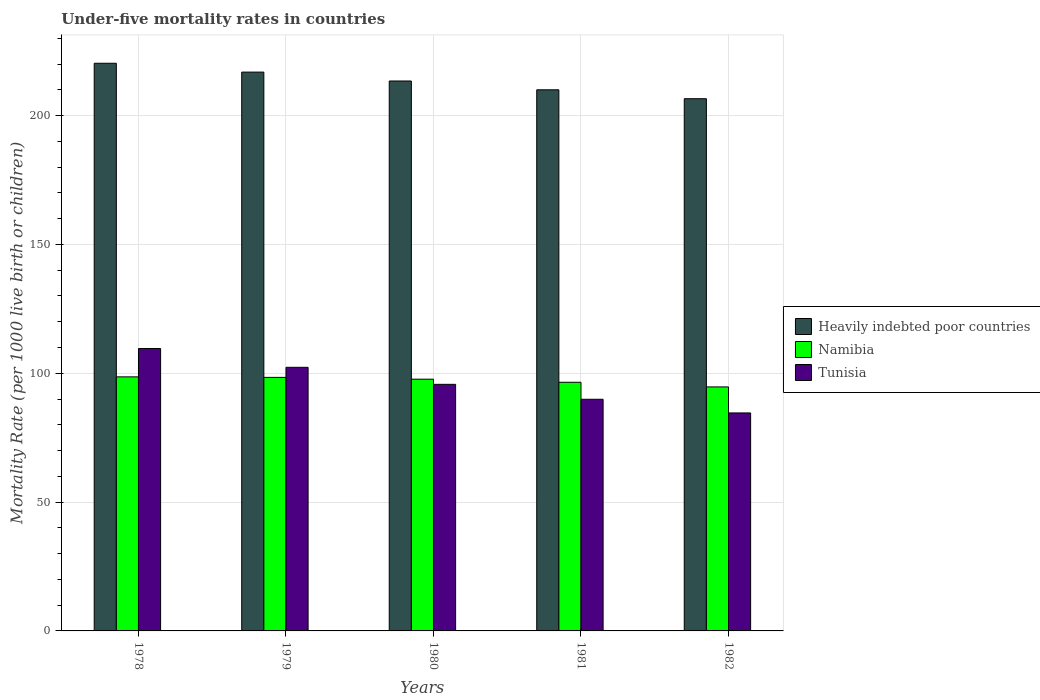In how many cases, is the number of bars for a given year not equal to the number of legend labels?
Your response must be concise. 0. What is the under-five mortality rate in Namibia in 1980?
Offer a very short reply. 97.7. Across all years, what is the maximum under-five mortality rate in Tunisia?
Provide a short and direct response. 109.6. Across all years, what is the minimum under-five mortality rate in Namibia?
Your answer should be very brief. 94.7. In which year was the under-five mortality rate in Heavily indebted poor countries maximum?
Offer a terse response. 1978. What is the total under-five mortality rate in Namibia in the graph?
Give a very brief answer. 485.9. What is the difference between the under-five mortality rate in Tunisia in 1981 and that in 1982?
Keep it short and to the point. 5.3. What is the difference between the under-five mortality rate in Heavily indebted poor countries in 1981 and the under-five mortality rate in Namibia in 1979?
Your response must be concise. 111.61. What is the average under-five mortality rate in Tunisia per year?
Provide a short and direct response. 96.42. In how many years, is the under-five mortality rate in Namibia greater than 120?
Ensure brevity in your answer.  0. What is the ratio of the under-five mortality rate in Heavily indebted poor countries in 1979 to that in 1981?
Keep it short and to the point. 1.03. Is the under-five mortality rate in Namibia in 1979 less than that in 1982?
Offer a very short reply. No. What is the difference between the highest and the second highest under-five mortality rate in Heavily indebted poor countries?
Your answer should be compact. 3.43. What is the difference between the highest and the lowest under-five mortality rate in Namibia?
Your answer should be compact. 3.9. In how many years, is the under-five mortality rate in Heavily indebted poor countries greater than the average under-five mortality rate in Heavily indebted poor countries taken over all years?
Provide a short and direct response. 2. Is the sum of the under-five mortality rate in Tunisia in 1979 and 1982 greater than the maximum under-five mortality rate in Heavily indebted poor countries across all years?
Give a very brief answer. No. What does the 2nd bar from the left in 1980 represents?
Your response must be concise. Namibia. What does the 2nd bar from the right in 1981 represents?
Your answer should be compact. Namibia. Is it the case that in every year, the sum of the under-five mortality rate in Heavily indebted poor countries and under-five mortality rate in Namibia is greater than the under-five mortality rate in Tunisia?
Provide a short and direct response. Yes. How many years are there in the graph?
Ensure brevity in your answer.  5. What is the difference between two consecutive major ticks on the Y-axis?
Offer a very short reply. 50. Are the values on the major ticks of Y-axis written in scientific E-notation?
Keep it short and to the point. No. Does the graph contain grids?
Keep it short and to the point. Yes. Where does the legend appear in the graph?
Your answer should be compact. Center right. How many legend labels are there?
Your answer should be very brief. 3. How are the legend labels stacked?
Keep it short and to the point. Vertical. What is the title of the graph?
Ensure brevity in your answer.  Under-five mortality rates in countries. Does "Kosovo" appear as one of the legend labels in the graph?
Your answer should be compact. No. What is the label or title of the X-axis?
Ensure brevity in your answer.  Years. What is the label or title of the Y-axis?
Ensure brevity in your answer.  Mortality Rate (per 1000 live birth or children). What is the Mortality Rate (per 1000 live birth or children) of Heavily indebted poor countries in 1978?
Provide a short and direct response. 220.31. What is the Mortality Rate (per 1000 live birth or children) in Namibia in 1978?
Provide a succinct answer. 98.6. What is the Mortality Rate (per 1000 live birth or children) in Tunisia in 1978?
Ensure brevity in your answer.  109.6. What is the Mortality Rate (per 1000 live birth or children) of Heavily indebted poor countries in 1979?
Ensure brevity in your answer.  216.87. What is the Mortality Rate (per 1000 live birth or children) in Namibia in 1979?
Give a very brief answer. 98.4. What is the Mortality Rate (per 1000 live birth or children) of Tunisia in 1979?
Offer a terse response. 102.3. What is the Mortality Rate (per 1000 live birth or children) in Heavily indebted poor countries in 1980?
Make the answer very short. 213.42. What is the Mortality Rate (per 1000 live birth or children) of Namibia in 1980?
Keep it short and to the point. 97.7. What is the Mortality Rate (per 1000 live birth or children) of Tunisia in 1980?
Your response must be concise. 95.7. What is the Mortality Rate (per 1000 live birth or children) of Heavily indebted poor countries in 1981?
Offer a very short reply. 210.01. What is the Mortality Rate (per 1000 live birth or children) of Namibia in 1981?
Ensure brevity in your answer.  96.5. What is the Mortality Rate (per 1000 live birth or children) in Tunisia in 1981?
Your answer should be very brief. 89.9. What is the Mortality Rate (per 1000 live birth or children) of Heavily indebted poor countries in 1982?
Keep it short and to the point. 206.55. What is the Mortality Rate (per 1000 live birth or children) in Namibia in 1982?
Your answer should be very brief. 94.7. What is the Mortality Rate (per 1000 live birth or children) of Tunisia in 1982?
Offer a terse response. 84.6. Across all years, what is the maximum Mortality Rate (per 1000 live birth or children) in Heavily indebted poor countries?
Make the answer very short. 220.31. Across all years, what is the maximum Mortality Rate (per 1000 live birth or children) in Namibia?
Your response must be concise. 98.6. Across all years, what is the maximum Mortality Rate (per 1000 live birth or children) of Tunisia?
Your answer should be very brief. 109.6. Across all years, what is the minimum Mortality Rate (per 1000 live birth or children) in Heavily indebted poor countries?
Provide a succinct answer. 206.55. Across all years, what is the minimum Mortality Rate (per 1000 live birth or children) in Namibia?
Your answer should be compact. 94.7. Across all years, what is the minimum Mortality Rate (per 1000 live birth or children) in Tunisia?
Offer a very short reply. 84.6. What is the total Mortality Rate (per 1000 live birth or children) in Heavily indebted poor countries in the graph?
Give a very brief answer. 1067.16. What is the total Mortality Rate (per 1000 live birth or children) of Namibia in the graph?
Ensure brevity in your answer.  485.9. What is the total Mortality Rate (per 1000 live birth or children) of Tunisia in the graph?
Ensure brevity in your answer.  482.1. What is the difference between the Mortality Rate (per 1000 live birth or children) in Heavily indebted poor countries in 1978 and that in 1979?
Give a very brief answer. 3.43. What is the difference between the Mortality Rate (per 1000 live birth or children) in Heavily indebted poor countries in 1978 and that in 1980?
Your answer should be compact. 6.89. What is the difference between the Mortality Rate (per 1000 live birth or children) of Namibia in 1978 and that in 1980?
Make the answer very short. 0.9. What is the difference between the Mortality Rate (per 1000 live birth or children) in Tunisia in 1978 and that in 1980?
Your answer should be compact. 13.9. What is the difference between the Mortality Rate (per 1000 live birth or children) of Heavily indebted poor countries in 1978 and that in 1981?
Offer a very short reply. 10.3. What is the difference between the Mortality Rate (per 1000 live birth or children) in Tunisia in 1978 and that in 1981?
Offer a terse response. 19.7. What is the difference between the Mortality Rate (per 1000 live birth or children) of Heavily indebted poor countries in 1978 and that in 1982?
Offer a very short reply. 13.76. What is the difference between the Mortality Rate (per 1000 live birth or children) of Namibia in 1978 and that in 1982?
Your response must be concise. 3.9. What is the difference between the Mortality Rate (per 1000 live birth or children) of Tunisia in 1978 and that in 1982?
Give a very brief answer. 25. What is the difference between the Mortality Rate (per 1000 live birth or children) in Heavily indebted poor countries in 1979 and that in 1980?
Offer a terse response. 3.45. What is the difference between the Mortality Rate (per 1000 live birth or children) of Tunisia in 1979 and that in 1980?
Ensure brevity in your answer.  6.6. What is the difference between the Mortality Rate (per 1000 live birth or children) of Heavily indebted poor countries in 1979 and that in 1981?
Make the answer very short. 6.87. What is the difference between the Mortality Rate (per 1000 live birth or children) in Namibia in 1979 and that in 1981?
Offer a terse response. 1.9. What is the difference between the Mortality Rate (per 1000 live birth or children) of Tunisia in 1979 and that in 1981?
Your answer should be compact. 12.4. What is the difference between the Mortality Rate (per 1000 live birth or children) of Heavily indebted poor countries in 1979 and that in 1982?
Your response must be concise. 10.32. What is the difference between the Mortality Rate (per 1000 live birth or children) in Namibia in 1979 and that in 1982?
Your answer should be compact. 3.7. What is the difference between the Mortality Rate (per 1000 live birth or children) of Tunisia in 1979 and that in 1982?
Provide a short and direct response. 17.7. What is the difference between the Mortality Rate (per 1000 live birth or children) of Heavily indebted poor countries in 1980 and that in 1981?
Your response must be concise. 3.42. What is the difference between the Mortality Rate (per 1000 live birth or children) in Namibia in 1980 and that in 1981?
Offer a very short reply. 1.2. What is the difference between the Mortality Rate (per 1000 live birth or children) in Tunisia in 1980 and that in 1981?
Keep it short and to the point. 5.8. What is the difference between the Mortality Rate (per 1000 live birth or children) in Heavily indebted poor countries in 1980 and that in 1982?
Give a very brief answer. 6.87. What is the difference between the Mortality Rate (per 1000 live birth or children) of Tunisia in 1980 and that in 1982?
Ensure brevity in your answer.  11.1. What is the difference between the Mortality Rate (per 1000 live birth or children) of Heavily indebted poor countries in 1981 and that in 1982?
Your answer should be very brief. 3.46. What is the difference between the Mortality Rate (per 1000 live birth or children) in Namibia in 1981 and that in 1982?
Your answer should be very brief. 1.8. What is the difference between the Mortality Rate (per 1000 live birth or children) in Heavily indebted poor countries in 1978 and the Mortality Rate (per 1000 live birth or children) in Namibia in 1979?
Provide a succinct answer. 121.91. What is the difference between the Mortality Rate (per 1000 live birth or children) of Heavily indebted poor countries in 1978 and the Mortality Rate (per 1000 live birth or children) of Tunisia in 1979?
Keep it short and to the point. 118.01. What is the difference between the Mortality Rate (per 1000 live birth or children) in Heavily indebted poor countries in 1978 and the Mortality Rate (per 1000 live birth or children) in Namibia in 1980?
Keep it short and to the point. 122.61. What is the difference between the Mortality Rate (per 1000 live birth or children) of Heavily indebted poor countries in 1978 and the Mortality Rate (per 1000 live birth or children) of Tunisia in 1980?
Keep it short and to the point. 124.61. What is the difference between the Mortality Rate (per 1000 live birth or children) of Heavily indebted poor countries in 1978 and the Mortality Rate (per 1000 live birth or children) of Namibia in 1981?
Make the answer very short. 123.81. What is the difference between the Mortality Rate (per 1000 live birth or children) of Heavily indebted poor countries in 1978 and the Mortality Rate (per 1000 live birth or children) of Tunisia in 1981?
Make the answer very short. 130.41. What is the difference between the Mortality Rate (per 1000 live birth or children) of Heavily indebted poor countries in 1978 and the Mortality Rate (per 1000 live birth or children) of Namibia in 1982?
Offer a terse response. 125.61. What is the difference between the Mortality Rate (per 1000 live birth or children) in Heavily indebted poor countries in 1978 and the Mortality Rate (per 1000 live birth or children) in Tunisia in 1982?
Keep it short and to the point. 135.71. What is the difference between the Mortality Rate (per 1000 live birth or children) in Namibia in 1978 and the Mortality Rate (per 1000 live birth or children) in Tunisia in 1982?
Provide a succinct answer. 14. What is the difference between the Mortality Rate (per 1000 live birth or children) in Heavily indebted poor countries in 1979 and the Mortality Rate (per 1000 live birth or children) in Namibia in 1980?
Offer a terse response. 119.17. What is the difference between the Mortality Rate (per 1000 live birth or children) in Heavily indebted poor countries in 1979 and the Mortality Rate (per 1000 live birth or children) in Tunisia in 1980?
Keep it short and to the point. 121.17. What is the difference between the Mortality Rate (per 1000 live birth or children) of Namibia in 1979 and the Mortality Rate (per 1000 live birth or children) of Tunisia in 1980?
Provide a short and direct response. 2.7. What is the difference between the Mortality Rate (per 1000 live birth or children) in Heavily indebted poor countries in 1979 and the Mortality Rate (per 1000 live birth or children) in Namibia in 1981?
Make the answer very short. 120.37. What is the difference between the Mortality Rate (per 1000 live birth or children) in Heavily indebted poor countries in 1979 and the Mortality Rate (per 1000 live birth or children) in Tunisia in 1981?
Provide a succinct answer. 126.97. What is the difference between the Mortality Rate (per 1000 live birth or children) of Heavily indebted poor countries in 1979 and the Mortality Rate (per 1000 live birth or children) of Namibia in 1982?
Make the answer very short. 122.17. What is the difference between the Mortality Rate (per 1000 live birth or children) in Heavily indebted poor countries in 1979 and the Mortality Rate (per 1000 live birth or children) in Tunisia in 1982?
Give a very brief answer. 132.27. What is the difference between the Mortality Rate (per 1000 live birth or children) in Namibia in 1979 and the Mortality Rate (per 1000 live birth or children) in Tunisia in 1982?
Your answer should be very brief. 13.8. What is the difference between the Mortality Rate (per 1000 live birth or children) of Heavily indebted poor countries in 1980 and the Mortality Rate (per 1000 live birth or children) of Namibia in 1981?
Keep it short and to the point. 116.92. What is the difference between the Mortality Rate (per 1000 live birth or children) in Heavily indebted poor countries in 1980 and the Mortality Rate (per 1000 live birth or children) in Tunisia in 1981?
Provide a succinct answer. 123.52. What is the difference between the Mortality Rate (per 1000 live birth or children) in Heavily indebted poor countries in 1980 and the Mortality Rate (per 1000 live birth or children) in Namibia in 1982?
Keep it short and to the point. 118.72. What is the difference between the Mortality Rate (per 1000 live birth or children) of Heavily indebted poor countries in 1980 and the Mortality Rate (per 1000 live birth or children) of Tunisia in 1982?
Provide a succinct answer. 128.82. What is the difference between the Mortality Rate (per 1000 live birth or children) of Heavily indebted poor countries in 1981 and the Mortality Rate (per 1000 live birth or children) of Namibia in 1982?
Offer a very short reply. 115.31. What is the difference between the Mortality Rate (per 1000 live birth or children) in Heavily indebted poor countries in 1981 and the Mortality Rate (per 1000 live birth or children) in Tunisia in 1982?
Keep it short and to the point. 125.41. What is the difference between the Mortality Rate (per 1000 live birth or children) of Namibia in 1981 and the Mortality Rate (per 1000 live birth or children) of Tunisia in 1982?
Provide a succinct answer. 11.9. What is the average Mortality Rate (per 1000 live birth or children) in Heavily indebted poor countries per year?
Give a very brief answer. 213.43. What is the average Mortality Rate (per 1000 live birth or children) in Namibia per year?
Your response must be concise. 97.18. What is the average Mortality Rate (per 1000 live birth or children) of Tunisia per year?
Keep it short and to the point. 96.42. In the year 1978, what is the difference between the Mortality Rate (per 1000 live birth or children) in Heavily indebted poor countries and Mortality Rate (per 1000 live birth or children) in Namibia?
Give a very brief answer. 121.71. In the year 1978, what is the difference between the Mortality Rate (per 1000 live birth or children) in Heavily indebted poor countries and Mortality Rate (per 1000 live birth or children) in Tunisia?
Provide a short and direct response. 110.71. In the year 1978, what is the difference between the Mortality Rate (per 1000 live birth or children) of Namibia and Mortality Rate (per 1000 live birth or children) of Tunisia?
Your answer should be compact. -11. In the year 1979, what is the difference between the Mortality Rate (per 1000 live birth or children) of Heavily indebted poor countries and Mortality Rate (per 1000 live birth or children) of Namibia?
Give a very brief answer. 118.47. In the year 1979, what is the difference between the Mortality Rate (per 1000 live birth or children) of Heavily indebted poor countries and Mortality Rate (per 1000 live birth or children) of Tunisia?
Make the answer very short. 114.57. In the year 1980, what is the difference between the Mortality Rate (per 1000 live birth or children) of Heavily indebted poor countries and Mortality Rate (per 1000 live birth or children) of Namibia?
Give a very brief answer. 115.72. In the year 1980, what is the difference between the Mortality Rate (per 1000 live birth or children) in Heavily indebted poor countries and Mortality Rate (per 1000 live birth or children) in Tunisia?
Offer a terse response. 117.72. In the year 1981, what is the difference between the Mortality Rate (per 1000 live birth or children) of Heavily indebted poor countries and Mortality Rate (per 1000 live birth or children) of Namibia?
Make the answer very short. 113.51. In the year 1981, what is the difference between the Mortality Rate (per 1000 live birth or children) of Heavily indebted poor countries and Mortality Rate (per 1000 live birth or children) of Tunisia?
Ensure brevity in your answer.  120.11. In the year 1982, what is the difference between the Mortality Rate (per 1000 live birth or children) in Heavily indebted poor countries and Mortality Rate (per 1000 live birth or children) in Namibia?
Offer a very short reply. 111.85. In the year 1982, what is the difference between the Mortality Rate (per 1000 live birth or children) of Heavily indebted poor countries and Mortality Rate (per 1000 live birth or children) of Tunisia?
Give a very brief answer. 121.95. What is the ratio of the Mortality Rate (per 1000 live birth or children) in Heavily indebted poor countries in 1978 to that in 1979?
Make the answer very short. 1.02. What is the ratio of the Mortality Rate (per 1000 live birth or children) in Tunisia in 1978 to that in 1979?
Your answer should be compact. 1.07. What is the ratio of the Mortality Rate (per 1000 live birth or children) of Heavily indebted poor countries in 1978 to that in 1980?
Your response must be concise. 1.03. What is the ratio of the Mortality Rate (per 1000 live birth or children) of Namibia in 1978 to that in 1980?
Keep it short and to the point. 1.01. What is the ratio of the Mortality Rate (per 1000 live birth or children) in Tunisia in 1978 to that in 1980?
Offer a very short reply. 1.15. What is the ratio of the Mortality Rate (per 1000 live birth or children) of Heavily indebted poor countries in 1978 to that in 1981?
Provide a short and direct response. 1.05. What is the ratio of the Mortality Rate (per 1000 live birth or children) of Namibia in 1978 to that in 1981?
Ensure brevity in your answer.  1.02. What is the ratio of the Mortality Rate (per 1000 live birth or children) in Tunisia in 1978 to that in 1981?
Keep it short and to the point. 1.22. What is the ratio of the Mortality Rate (per 1000 live birth or children) in Heavily indebted poor countries in 1978 to that in 1982?
Your answer should be compact. 1.07. What is the ratio of the Mortality Rate (per 1000 live birth or children) in Namibia in 1978 to that in 1982?
Give a very brief answer. 1.04. What is the ratio of the Mortality Rate (per 1000 live birth or children) in Tunisia in 1978 to that in 1982?
Your answer should be very brief. 1.3. What is the ratio of the Mortality Rate (per 1000 live birth or children) of Heavily indebted poor countries in 1979 to that in 1980?
Your response must be concise. 1.02. What is the ratio of the Mortality Rate (per 1000 live birth or children) in Tunisia in 1979 to that in 1980?
Your answer should be very brief. 1.07. What is the ratio of the Mortality Rate (per 1000 live birth or children) in Heavily indebted poor countries in 1979 to that in 1981?
Keep it short and to the point. 1.03. What is the ratio of the Mortality Rate (per 1000 live birth or children) in Namibia in 1979 to that in 1981?
Ensure brevity in your answer.  1.02. What is the ratio of the Mortality Rate (per 1000 live birth or children) in Tunisia in 1979 to that in 1981?
Your answer should be very brief. 1.14. What is the ratio of the Mortality Rate (per 1000 live birth or children) in Heavily indebted poor countries in 1979 to that in 1982?
Offer a very short reply. 1.05. What is the ratio of the Mortality Rate (per 1000 live birth or children) of Namibia in 1979 to that in 1982?
Ensure brevity in your answer.  1.04. What is the ratio of the Mortality Rate (per 1000 live birth or children) of Tunisia in 1979 to that in 1982?
Provide a succinct answer. 1.21. What is the ratio of the Mortality Rate (per 1000 live birth or children) in Heavily indebted poor countries in 1980 to that in 1981?
Your response must be concise. 1.02. What is the ratio of the Mortality Rate (per 1000 live birth or children) of Namibia in 1980 to that in 1981?
Give a very brief answer. 1.01. What is the ratio of the Mortality Rate (per 1000 live birth or children) in Tunisia in 1980 to that in 1981?
Give a very brief answer. 1.06. What is the ratio of the Mortality Rate (per 1000 live birth or children) of Heavily indebted poor countries in 1980 to that in 1982?
Ensure brevity in your answer.  1.03. What is the ratio of the Mortality Rate (per 1000 live birth or children) in Namibia in 1980 to that in 1982?
Offer a terse response. 1.03. What is the ratio of the Mortality Rate (per 1000 live birth or children) in Tunisia in 1980 to that in 1982?
Offer a very short reply. 1.13. What is the ratio of the Mortality Rate (per 1000 live birth or children) in Heavily indebted poor countries in 1981 to that in 1982?
Keep it short and to the point. 1.02. What is the ratio of the Mortality Rate (per 1000 live birth or children) in Namibia in 1981 to that in 1982?
Provide a succinct answer. 1.02. What is the ratio of the Mortality Rate (per 1000 live birth or children) in Tunisia in 1981 to that in 1982?
Offer a terse response. 1.06. What is the difference between the highest and the second highest Mortality Rate (per 1000 live birth or children) in Heavily indebted poor countries?
Offer a very short reply. 3.43. What is the difference between the highest and the second highest Mortality Rate (per 1000 live birth or children) in Tunisia?
Make the answer very short. 7.3. What is the difference between the highest and the lowest Mortality Rate (per 1000 live birth or children) in Heavily indebted poor countries?
Ensure brevity in your answer.  13.76. What is the difference between the highest and the lowest Mortality Rate (per 1000 live birth or children) in Namibia?
Provide a short and direct response. 3.9. What is the difference between the highest and the lowest Mortality Rate (per 1000 live birth or children) of Tunisia?
Make the answer very short. 25. 